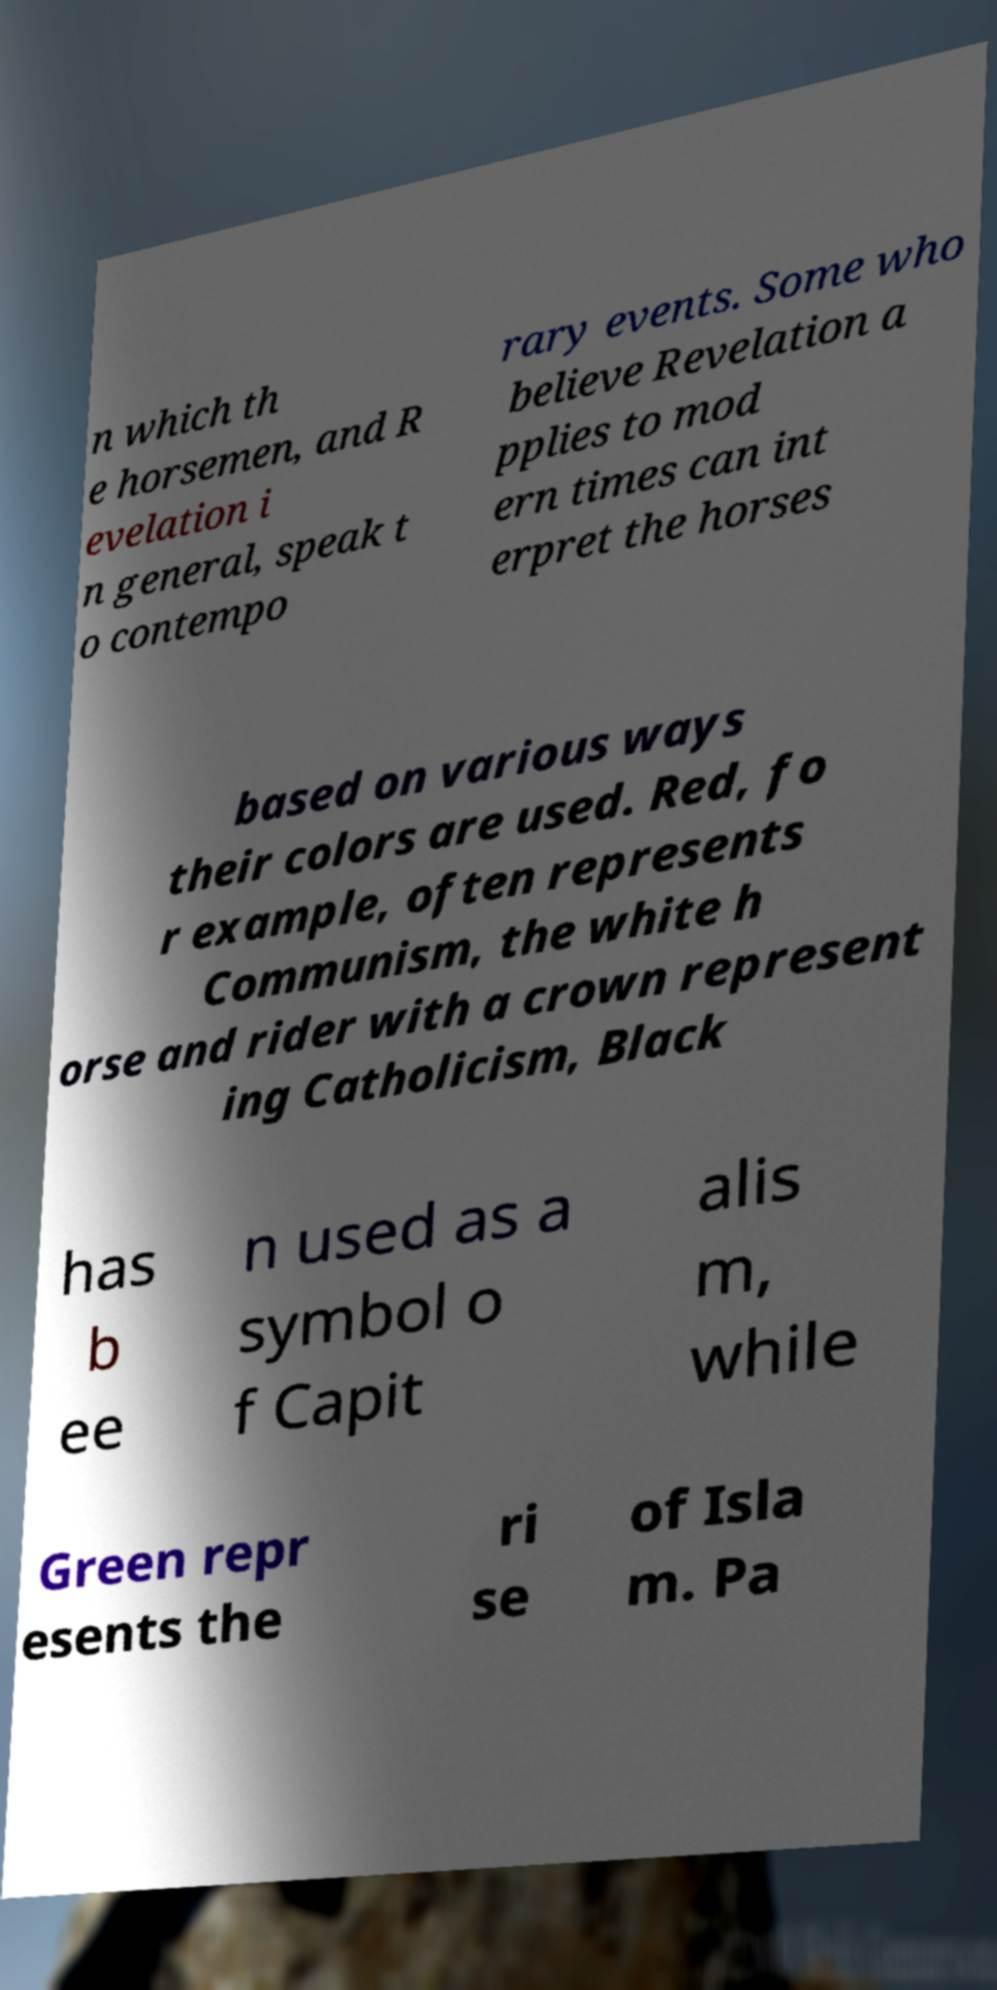For documentation purposes, I need the text within this image transcribed. Could you provide that? n which th e horsemen, and R evelation i n general, speak t o contempo rary events. Some who believe Revelation a pplies to mod ern times can int erpret the horses based on various ways their colors are used. Red, fo r example, often represents Communism, the white h orse and rider with a crown represent ing Catholicism, Black has b ee n used as a symbol o f Capit alis m, while Green repr esents the ri se of Isla m. Pa 